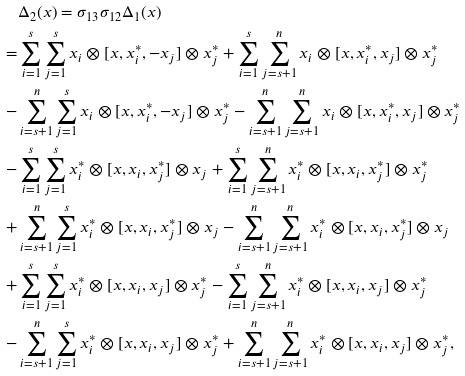<formula> <loc_0><loc_0><loc_500><loc_500>& \Delta _ { 2 } ( x ) = \sigma _ { 1 3 } \sigma _ { 1 2 } \Delta _ { 1 } ( x ) \\ = & \sum _ { i = 1 } ^ { s } \sum _ { j = 1 } ^ { s } x _ { i } \otimes [ x , x _ { i } ^ { * } , - x _ { j } ] \otimes x _ { j } ^ { * } + \sum _ { i = 1 } ^ { s } \sum _ { j = s + 1 } ^ { n } x _ { i } \otimes [ x , x _ { i } ^ { * } , x _ { j } ] \otimes x _ { j } ^ { * } \\ - & \sum _ { i = s + 1 } ^ { n } \sum _ { j = 1 } ^ { s } x _ { i } \otimes [ x , x _ { i } ^ { * } , - x _ { j } ] \otimes x _ { j } ^ { * } - \sum _ { i = s + 1 } ^ { n } \sum _ { j = s + 1 } ^ { n } x _ { i } \otimes [ x , x _ { i } ^ { * } , x _ { j } ] \otimes x _ { j } ^ { * } \\ - & \sum _ { i = 1 } ^ { s } \sum _ { j = 1 } ^ { s } x _ { i } ^ { * } \otimes [ x , x _ { i } , x _ { j } ^ { * } ] \otimes x _ { j } + \sum _ { i = 1 } ^ { s } \sum _ { j = s + 1 } ^ { n } x _ { i } ^ { * } \otimes [ x , x _ { i } , x _ { j } ^ { * } ] \otimes x _ { j } ^ { * } \\ + & \sum _ { i = s + 1 } ^ { n } \sum _ { j = 1 } ^ { s } x _ { i } ^ { * } \otimes [ x , x _ { i } , x _ { j } ^ { * } ] \otimes x _ { j } - \sum _ { i = s + 1 } ^ { n } \sum _ { j = s + 1 } ^ { n } x _ { i } ^ { * } \otimes [ x , x _ { i } , x _ { j } ^ { * } ] \otimes x _ { j } \\ + & \sum _ { i = 1 } ^ { s } \sum _ { j = 1 } ^ { s } x _ { i } ^ { * } \otimes [ x , x _ { i } , x _ { j } ] \otimes x _ { j } ^ { * } - \sum _ { i = 1 } ^ { s } \sum _ { j = s + 1 } ^ { n } x _ { i } ^ { * } \otimes [ x , x _ { i } , x _ { j } ] \otimes x _ { j } ^ { * } \\ - & \sum _ { i = s + 1 } ^ { n } \sum _ { j = 1 } ^ { s } x _ { i } ^ { * } \otimes [ x , x _ { i } , x _ { j } ] \otimes x _ { j } ^ { * } + \sum _ { i = s + 1 } ^ { n } \sum _ { j = s + 1 } ^ { n } x _ { i } ^ { * } \otimes [ x , x _ { i } , x _ { j } ] \otimes x _ { j } ^ { * } , \\</formula> 